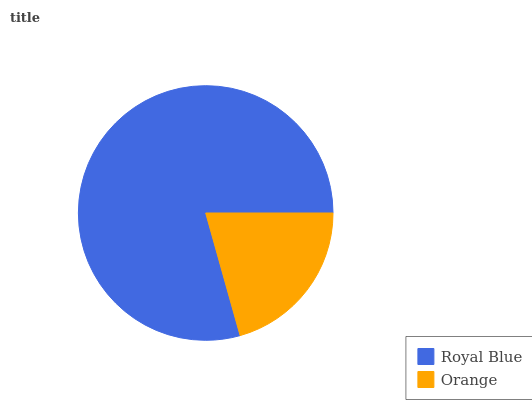Is Orange the minimum?
Answer yes or no. Yes. Is Royal Blue the maximum?
Answer yes or no. Yes. Is Orange the maximum?
Answer yes or no. No. Is Royal Blue greater than Orange?
Answer yes or no. Yes. Is Orange less than Royal Blue?
Answer yes or no. Yes. Is Orange greater than Royal Blue?
Answer yes or no. No. Is Royal Blue less than Orange?
Answer yes or no. No. Is Royal Blue the high median?
Answer yes or no. Yes. Is Orange the low median?
Answer yes or no. Yes. Is Orange the high median?
Answer yes or no. No. Is Royal Blue the low median?
Answer yes or no. No. 